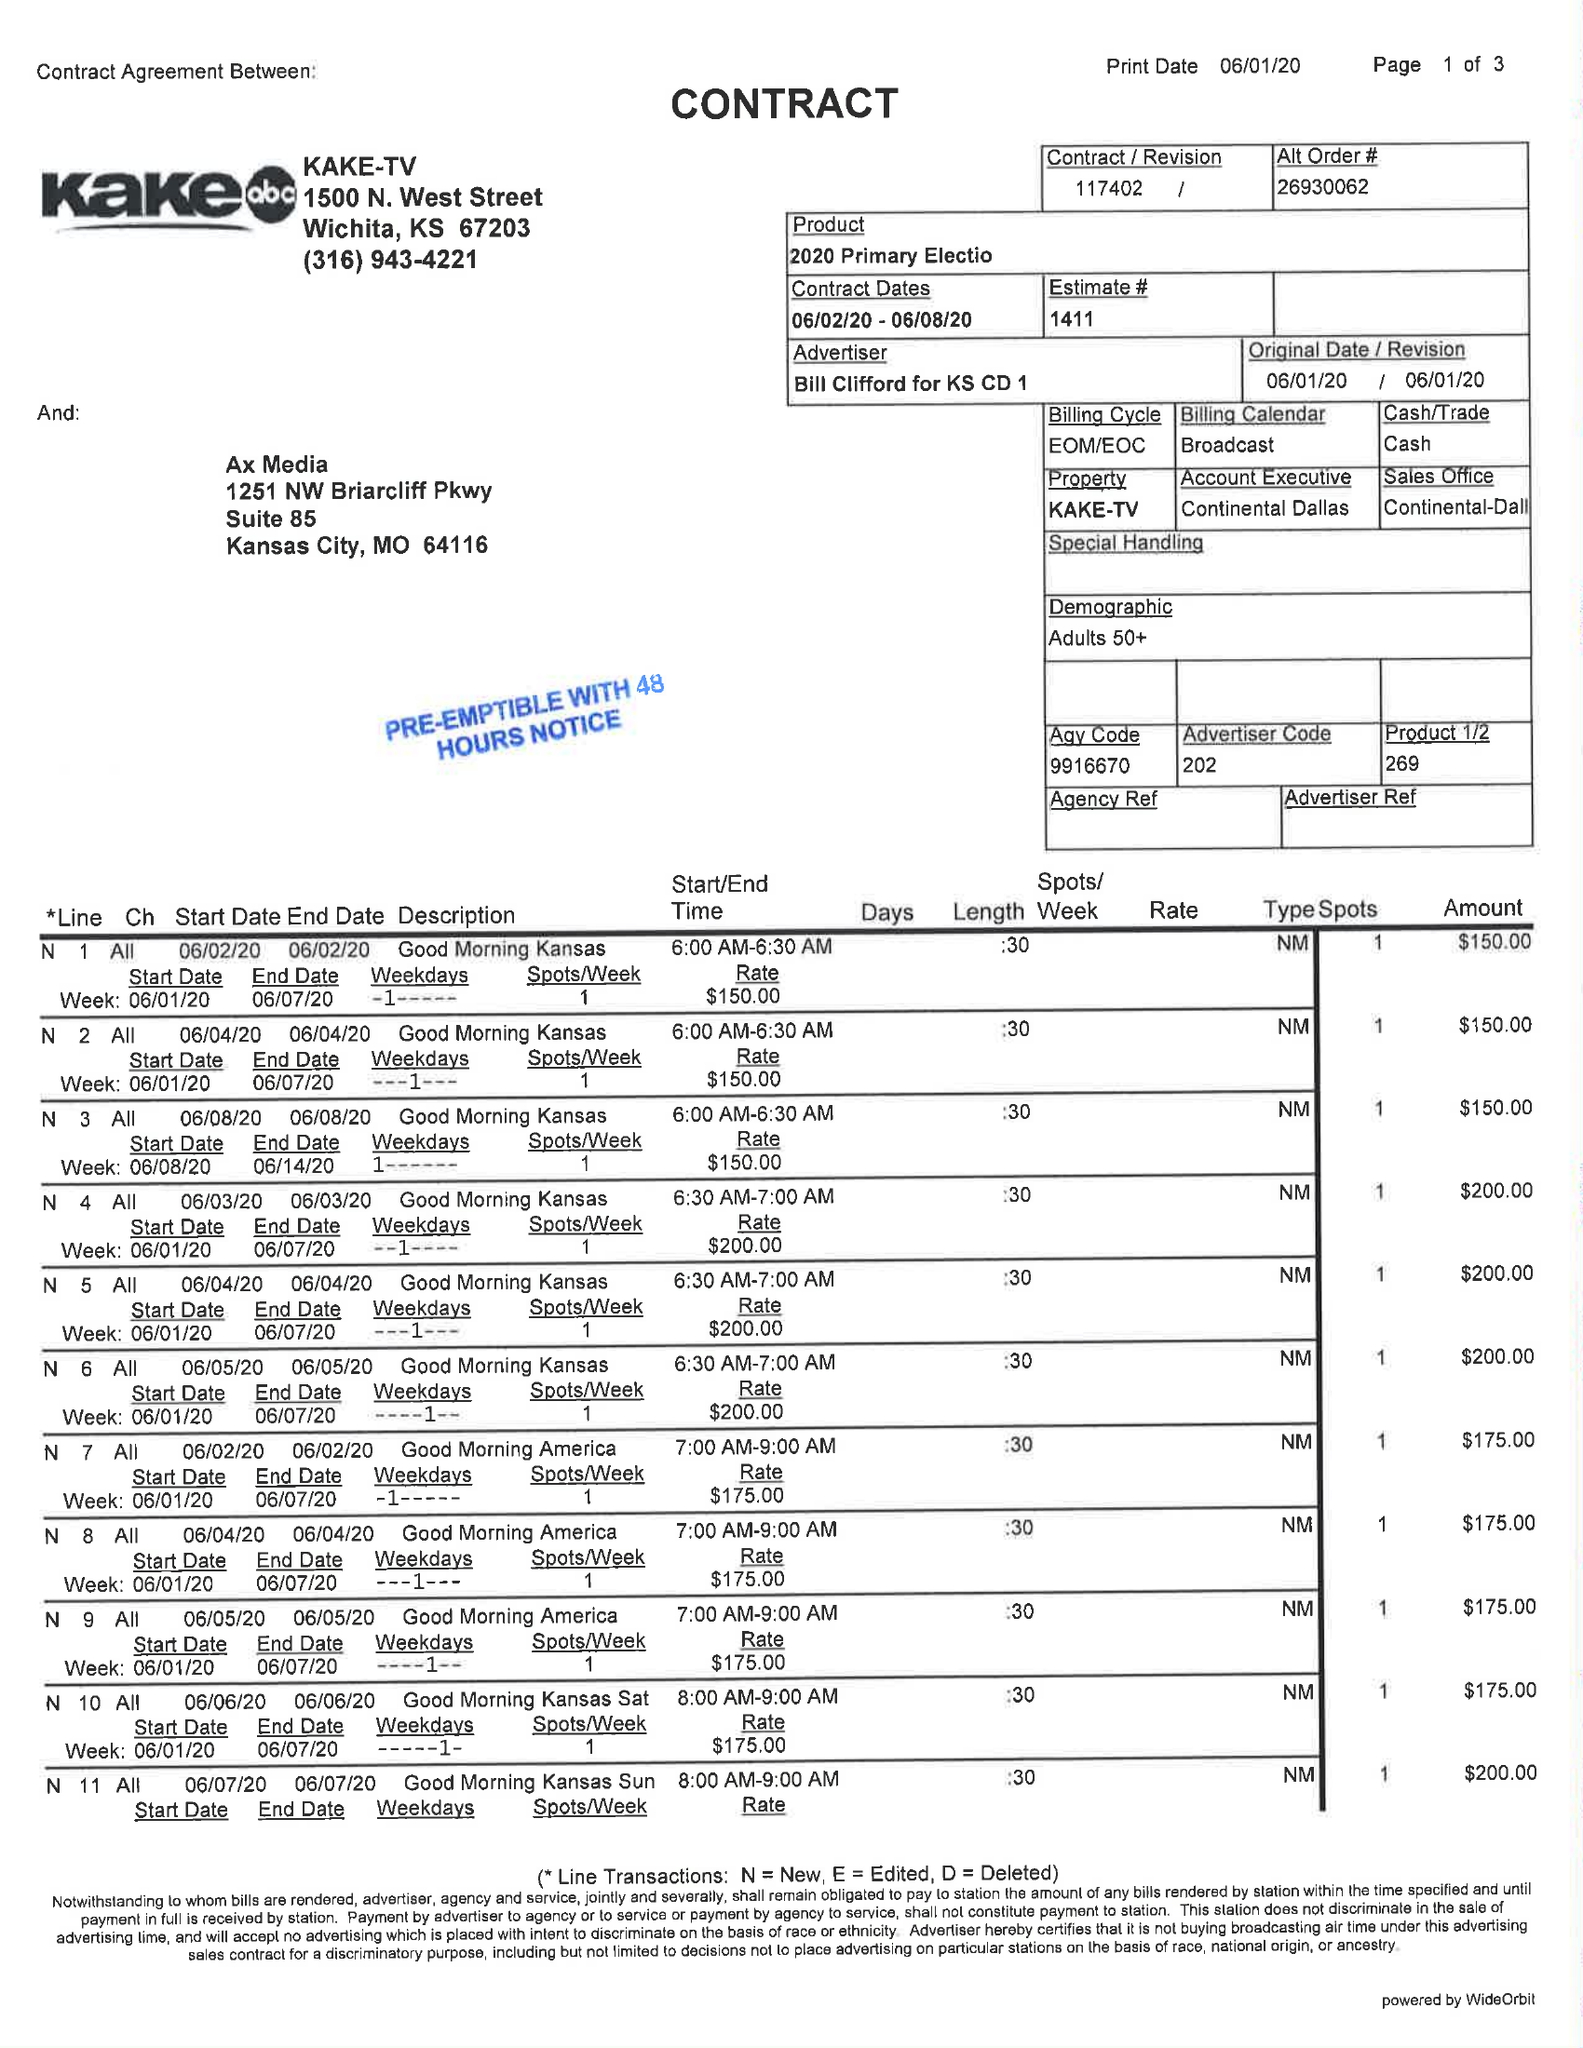What is the value for the flight_to?
Answer the question using a single word or phrase. 06/08/20 